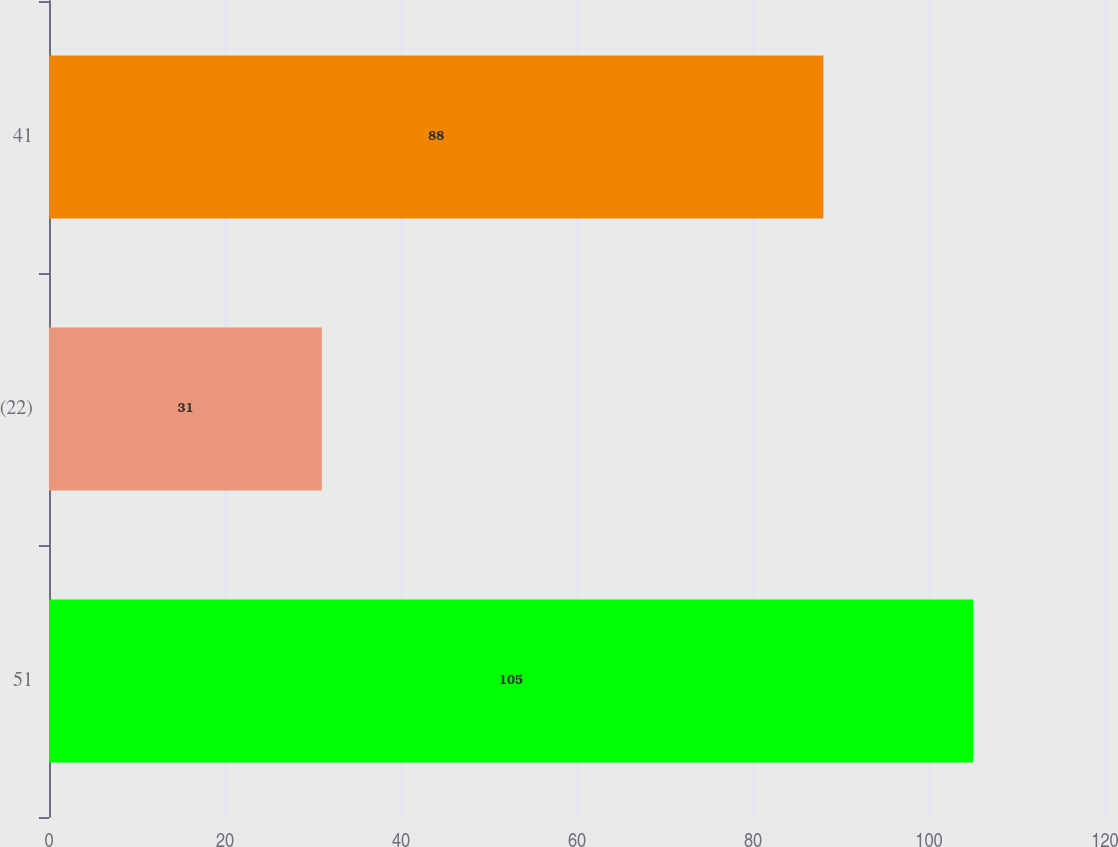<chart> <loc_0><loc_0><loc_500><loc_500><bar_chart><fcel>51<fcel>(22)<fcel>41<nl><fcel>105<fcel>31<fcel>88<nl></chart> 